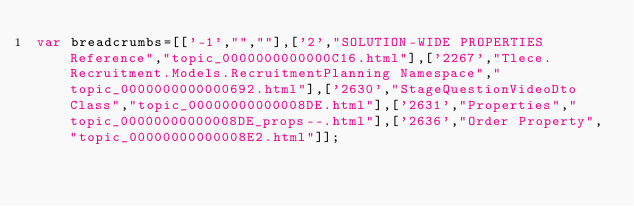<code> <loc_0><loc_0><loc_500><loc_500><_JavaScript_>var breadcrumbs=[['-1',"",""],['2',"SOLUTION-WIDE PROPERTIES Reference","topic_0000000000000C16.html"],['2267',"Tlece.Recruitment.Models.RecruitmentPlanning Namespace","topic_0000000000000692.html"],['2630',"StageQuestionVideoDto Class","topic_00000000000008DE.html"],['2631',"Properties","topic_00000000000008DE_props--.html"],['2636',"Order Property","topic_00000000000008E2.html"]];</code> 